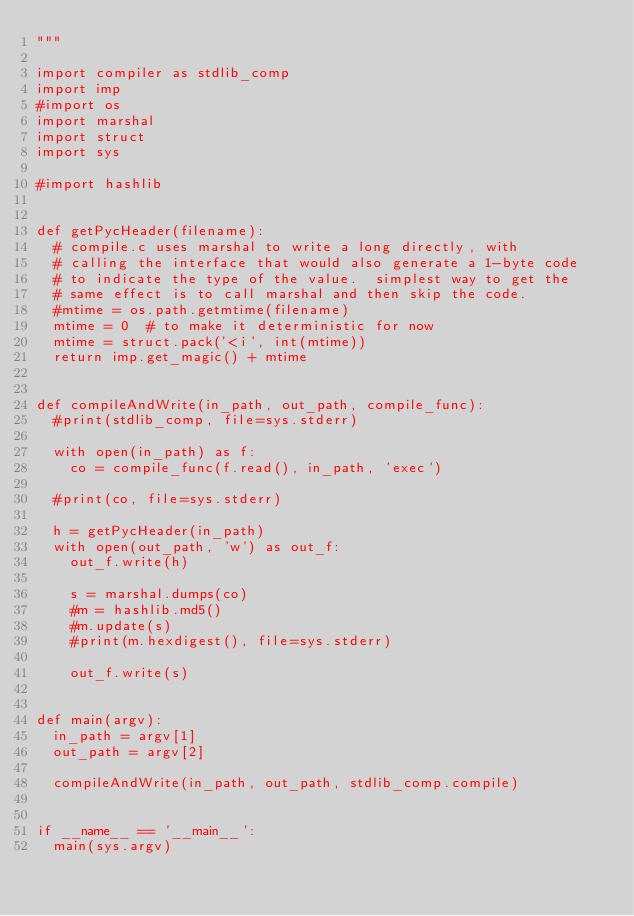<code> <loc_0><loc_0><loc_500><loc_500><_Python_>"""

import compiler as stdlib_comp
import imp
#import os
import marshal
import struct
import sys

#import hashlib


def getPycHeader(filename):
  # compile.c uses marshal to write a long directly, with
  # calling the interface that would also generate a 1-byte code
  # to indicate the type of the value.  simplest way to get the
  # same effect is to call marshal and then skip the code.
  #mtime = os.path.getmtime(filename)
  mtime = 0  # to make it deterministic for now
  mtime = struct.pack('<i', int(mtime))
  return imp.get_magic() + mtime


def compileAndWrite(in_path, out_path, compile_func):
  #print(stdlib_comp, file=sys.stderr)

  with open(in_path) as f:
    co = compile_func(f.read(), in_path, 'exec')

  #print(co, file=sys.stderr)

  h = getPycHeader(in_path)
  with open(out_path, 'w') as out_f:
    out_f.write(h)

    s = marshal.dumps(co)
    #m = hashlib.md5()
    #m.update(s)
    #print(m.hexdigest(), file=sys.stderr)

    out_f.write(s)


def main(argv):
  in_path = argv[1]
  out_path = argv[2]

  compileAndWrite(in_path, out_path, stdlib_comp.compile)


if __name__ == '__main__':
  main(sys.argv)
</code> 